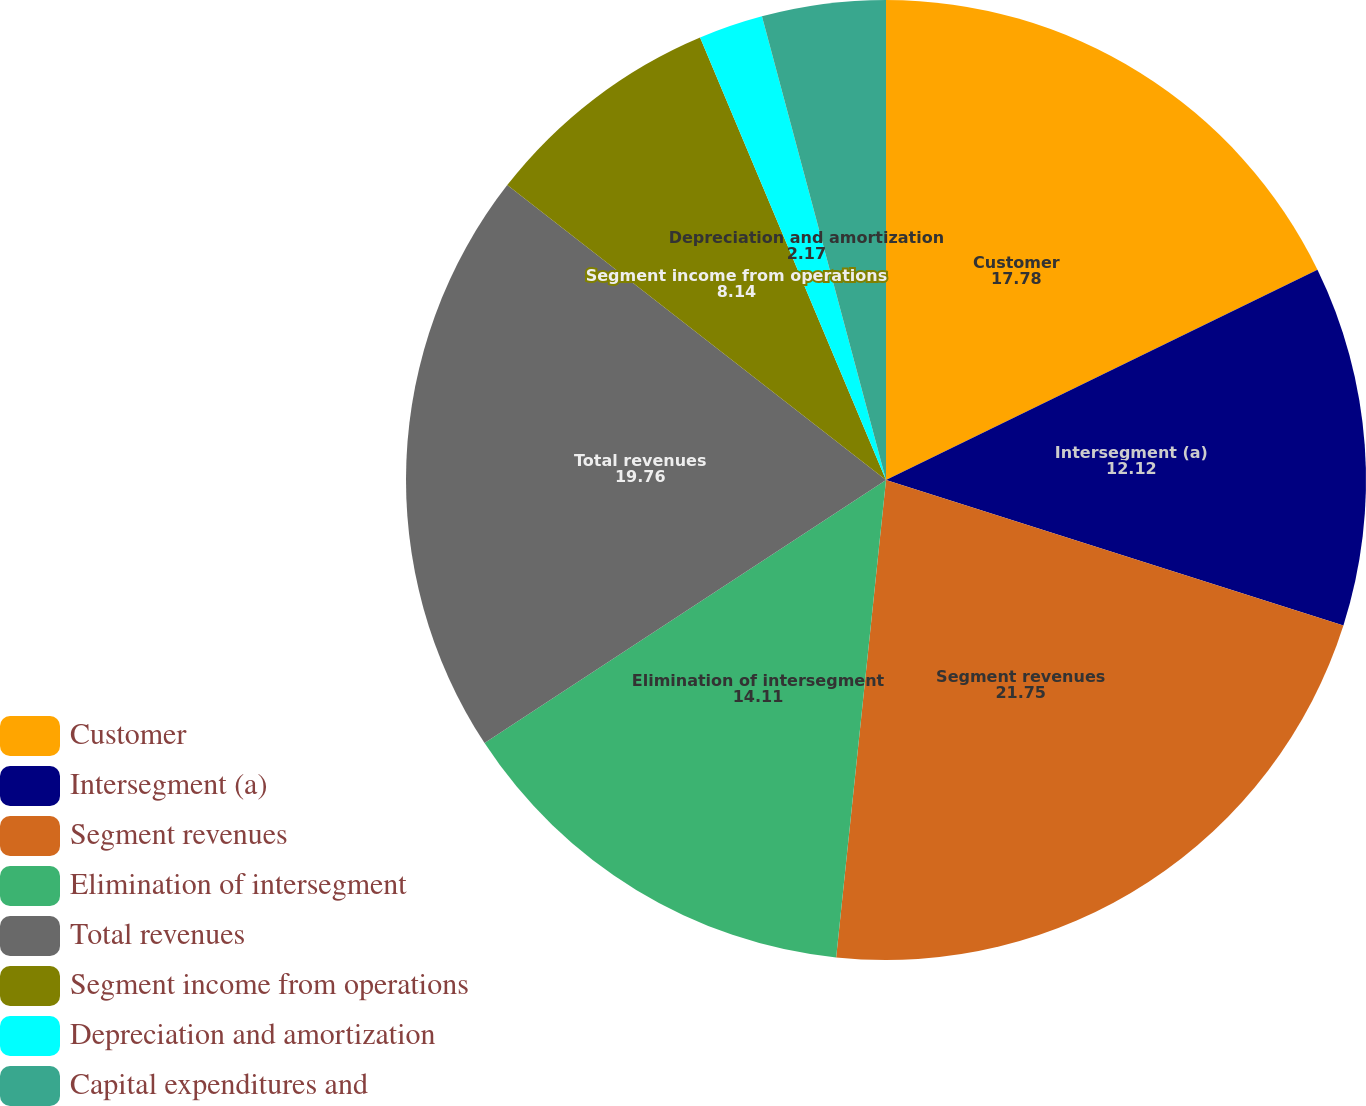Convert chart. <chart><loc_0><loc_0><loc_500><loc_500><pie_chart><fcel>Customer<fcel>Intersegment (a)<fcel>Segment revenues<fcel>Elimination of intersegment<fcel>Total revenues<fcel>Segment income from operations<fcel>Depreciation and amortization<fcel>Capital expenditures and<nl><fcel>17.78%<fcel>12.12%<fcel>21.75%<fcel>14.11%<fcel>19.76%<fcel>8.14%<fcel>2.17%<fcel>4.16%<nl></chart> 